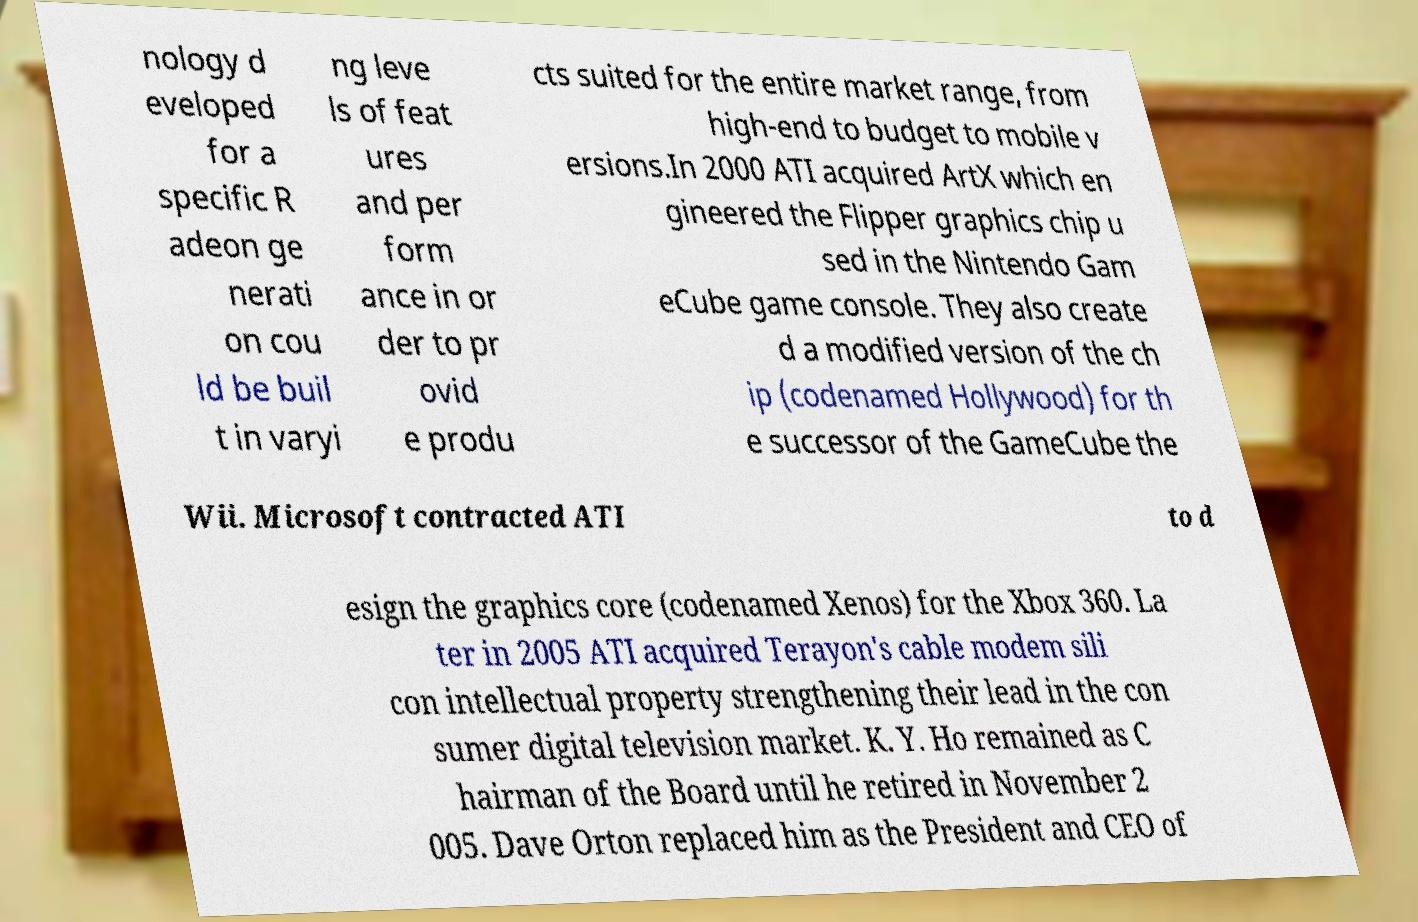Can you read and provide the text displayed in the image?This photo seems to have some interesting text. Can you extract and type it out for me? nology d eveloped for a specific R adeon ge nerati on cou ld be buil t in varyi ng leve ls of feat ures and per form ance in or der to pr ovid e produ cts suited for the entire market range, from high-end to budget to mobile v ersions.In 2000 ATI acquired ArtX which en gineered the Flipper graphics chip u sed in the Nintendo Gam eCube game console. They also create d a modified version of the ch ip (codenamed Hollywood) for th e successor of the GameCube the Wii. Microsoft contracted ATI to d esign the graphics core (codenamed Xenos) for the Xbox 360. La ter in 2005 ATI acquired Terayon's cable modem sili con intellectual property strengthening their lead in the con sumer digital television market. K. Y. Ho remained as C hairman of the Board until he retired in November 2 005. Dave Orton replaced him as the President and CEO of 